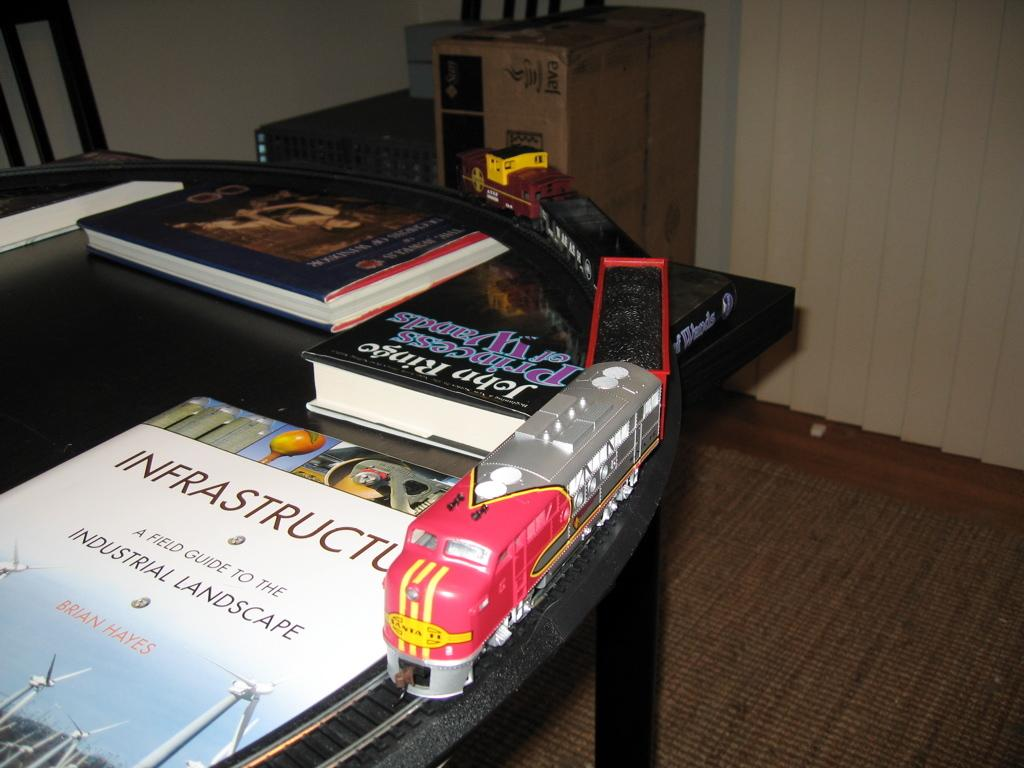Provide a one-sentence caption for the provided image. A train is on a table next to several books, one of which is called Infrastructure. 